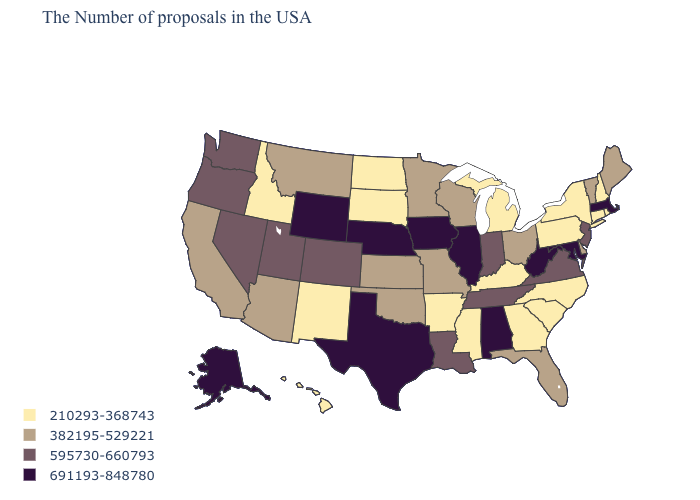Name the states that have a value in the range 382195-529221?
Be succinct. Maine, Vermont, Delaware, Ohio, Florida, Wisconsin, Missouri, Minnesota, Kansas, Oklahoma, Montana, Arizona, California. Which states hav the highest value in the MidWest?
Quick response, please. Illinois, Iowa, Nebraska. What is the value of Nebraska?
Short answer required. 691193-848780. What is the value of Minnesota?
Be succinct. 382195-529221. Does the map have missing data?
Give a very brief answer. No. What is the highest value in the USA?
Answer briefly. 691193-848780. What is the value of Tennessee?
Write a very short answer. 595730-660793. Does the map have missing data?
Short answer required. No. Name the states that have a value in the range 382195-529221?
Give a very brief answer. Maine, Vermont, Delaware, Ohio, Florida, Wisconsin, Missouri, Minnesota, Kansas, Oklahoma, Montana, Arizona, California. How many symbols are there in the legend?
Be succinct. 4. What is the value of Wisconsin?
Be succinct. 382195-529221. What is the highest value in the South ?
Give a very brief answer. 691193-848780. What is the value of Maryland?
Answer briefly. 691193-848780. How many symbols are there in the legend?
Answer briefly. 4. Name the states that have a value in the range 210293-368743?
Keep it brief. Rhode Island, New Hampshire, Connecticut, New York, Pennsylvania, North Carolina, South Carolina, Georgia, Michigan, Kentucky, Mississippi, Arkansas, South Dakota, North Dakota, New Mexico, Idaho, Hawaii. 